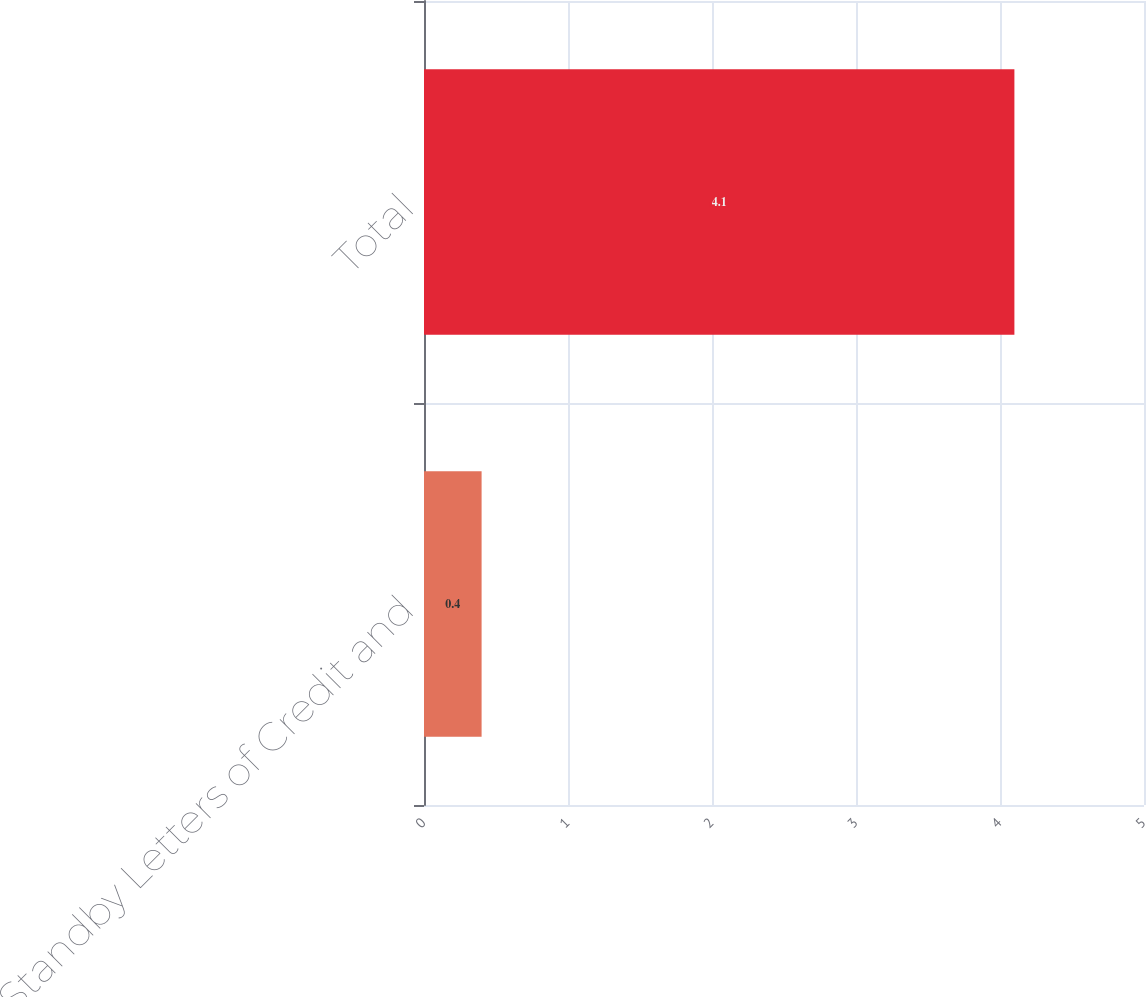<chart> <loc_0><loc_0><loc_500><loc_500><bar_chart><fcel>Standby Letters of Credit and<fcel>Total<nl><fcel>0.4<fcel>4.1<nl></chart> 